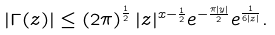<formula> <loc_0><loc_0><loc_500><loc_500>\left | \Gamma ( z ) \right | \leq \left ( 2 \pi \right ) ^ { \frac { 1 } { 2 } } | z | ^ { x - \frac { 1 } { 2 } } e ^ { - \frac { \pi | y | } { 2 } } e ^ { \frac { 1 } { 6 | z | } } .</formula> 